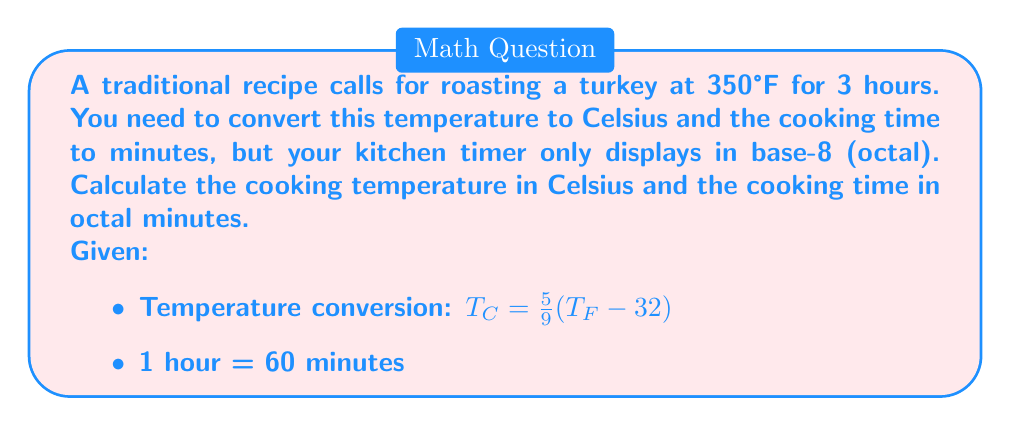What is the answer to this math problem? 1. Convert temperature from Fahrenheit to Celsius:
   $T_{C} = \frac{5}{9}(350 - 32)$
   $T_{C} = \frac{5}{9}(318)$
   $T_{C} = 176.67°C$
   Rounded to the nearest degree: $T_{C} = 177°C$

2. Convert cooking time from hours to minutes:
   3 hours = $3 \times 60 = 180$ minutes

3. Convert 180 (base 10) to base 8 (octal):
   To convert to octal, we divide by 8 repeatedly and keep track of the remainders:

   $180 \div 8 = 22$ remainder $4$
   $22 \div 8 = 2$ remainder $6$
   $2 \div 8 = 0$ remainder $2$

   Reading the remainders from bottom to top, we get:
   $180_{10} = 264_8$

Therefore, the cooking time in octal is $264_8$ minutes.
Answer: Temperature: 177°C
Cooking time: $264_8$ minutes (octal) 